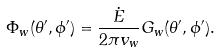<formula> <loc_0><loc_0><loc_500><loc_500>\Phi _ { w } ( \theta ^ { \prime } , \phi ^ { \prime } ) = \frac { \dot { E } } { 2 \pi v _ { w } } G _ { w } ( \theta ^ { \prime } , \phi ^ { \prime } ) .</formula> 